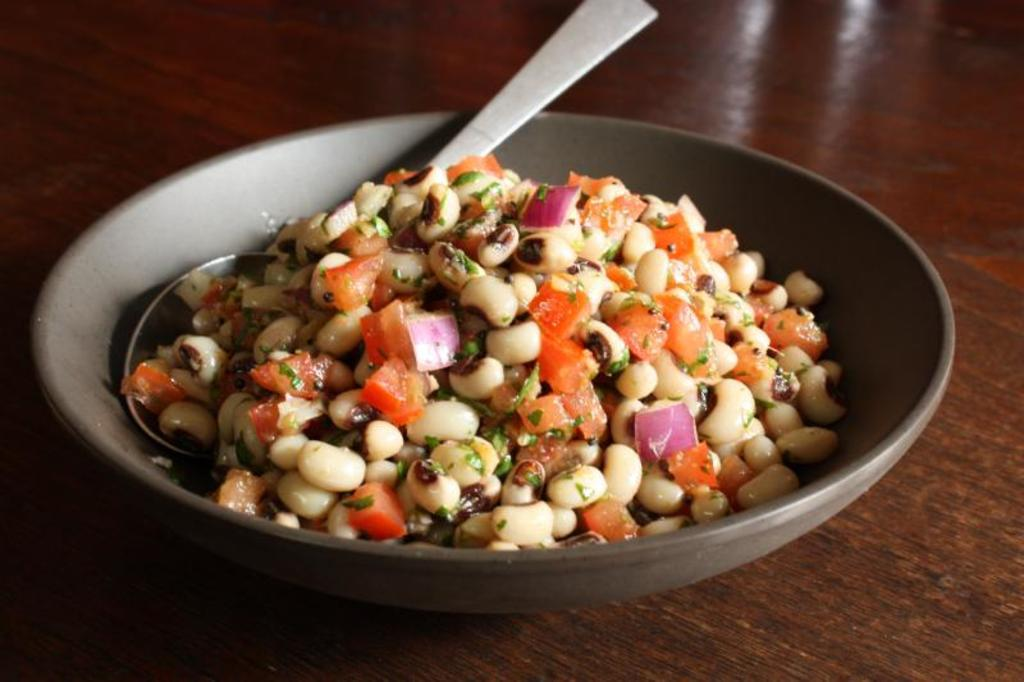What type of furniture is present in the image? There is a table in the image. What is in the bowl that is visible on the table? There is a bowl containing salad in the image. What utensil is placed on the table? A spoon is placed on the table. Can you tell me how many pieces of cheese are on the crib in the image? There is no crib or cheese present in the image. 